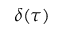<formula> <loc_0><loc_0><loc_500><loc_500>\delta ( \tau )</formula> 